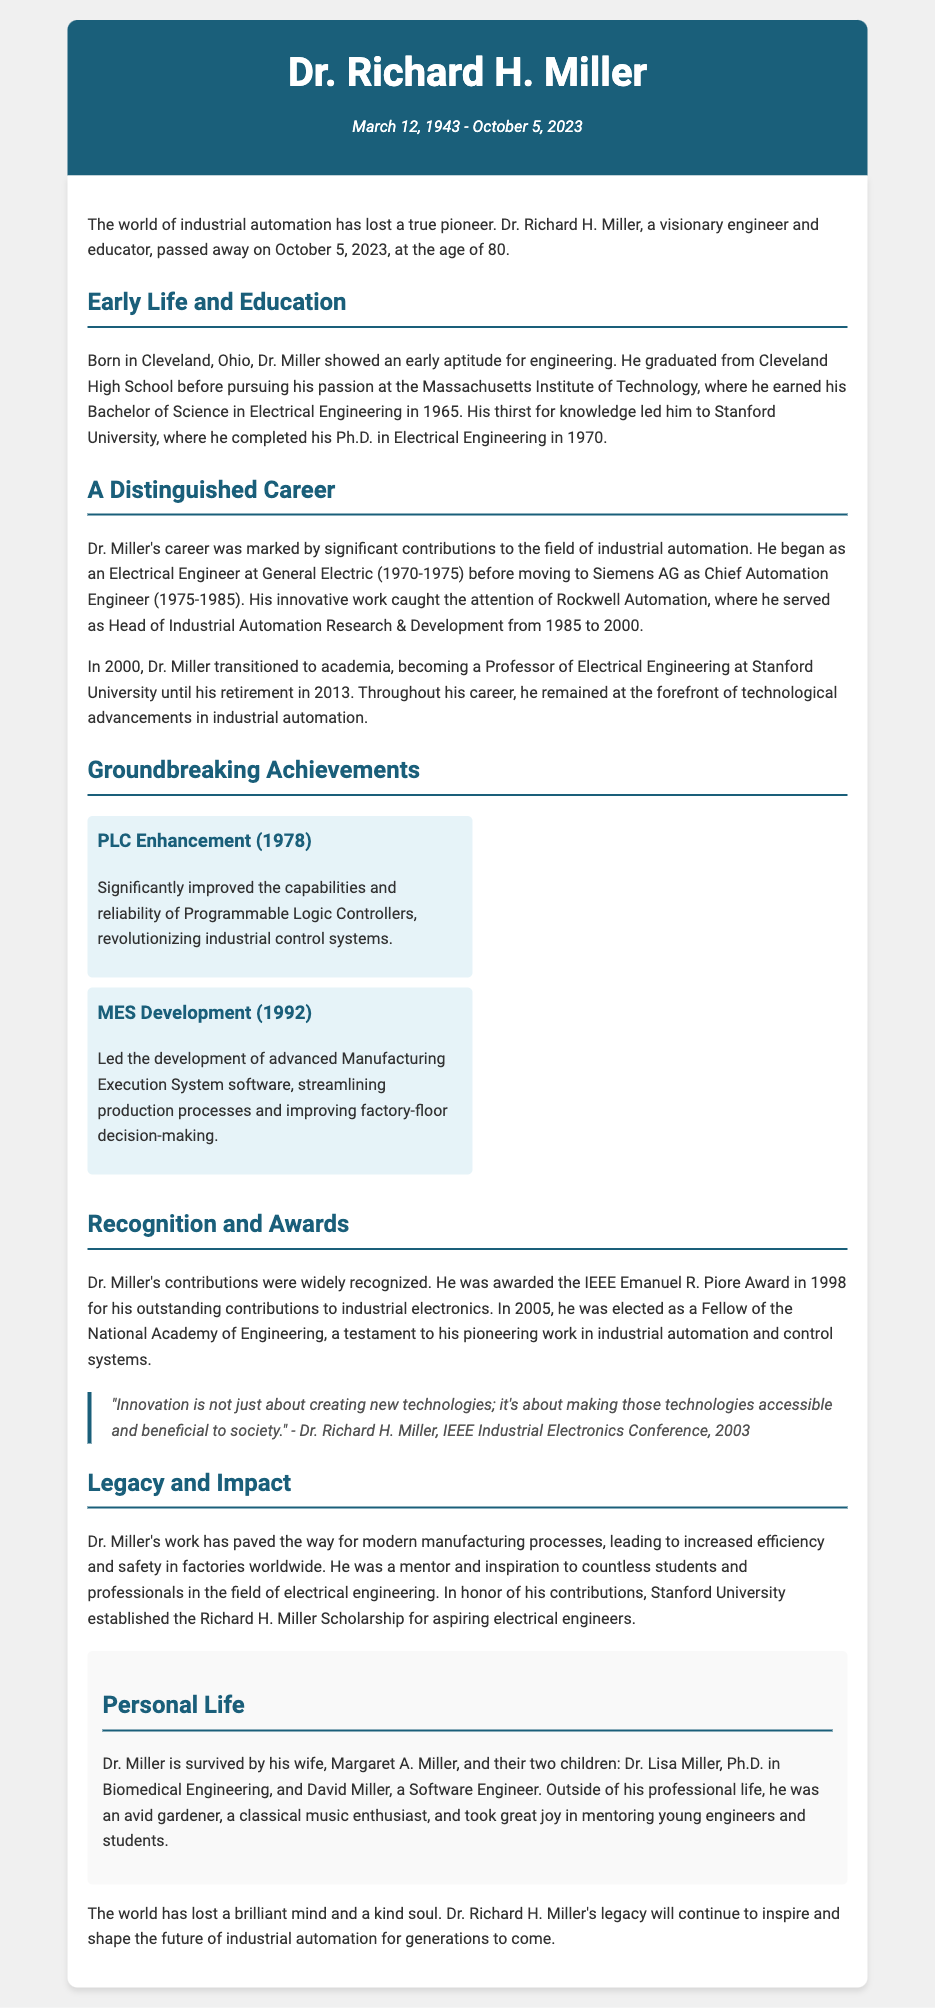What date did Dr. Richard H. Miller pass away? The document states that Dr. Miller passed away on October 5, 2023.
Answer: October 5, 2023 Where did Dr. Miller earn his Bachelor of Science degree? The document mentions that Dr. Miller earned his Bachelor of Science in Electrical Engineering from the Massachusetts Institute of Technology.
Answer: Massachusetts Institute of Technology What position did Dr. Miller hold at Rockwell Automation? According to the document, Dr. Miller served as Head of Industrial Automation Research & Development at Rockwell Automation.
Answer: Head of Industrial Automation Research & Development What significant achievement is associated with the year 1978? The document describes Dr. Miller's enhancement of Programmable Logic Controllers in 1978 as a significant achievement.
Answer: PLC Enhancement Which award did Dr. Miller receive in 1998? The document notes that Dr. Miller was awarded the IEEE Emanuel R. Piore Award in 1998.
Answer: IEEE Emanuel R. Piore Award What university established a scholarship in Dr. Miller's honor? The document indicated that Stanford University established the Richard H. Miller Scholarship in his honor.
Answer: Stanford University How many children did Dr. Miller have? The document states that Dr. Miller is survived by two children.
Answer: Two What is a notable personal interest of Dr. Miller mentioned in the document? The document highlights that Dr. Miller was an avid gardener as one of his personal interests.
Answer: Gardener What does the quote from Dr. Miller emphasize about innovation? The quote emphasizes that innovation is about accessibility and societal benefit, not just creating new technologies.
Answer: Accessibility and societal benefit 